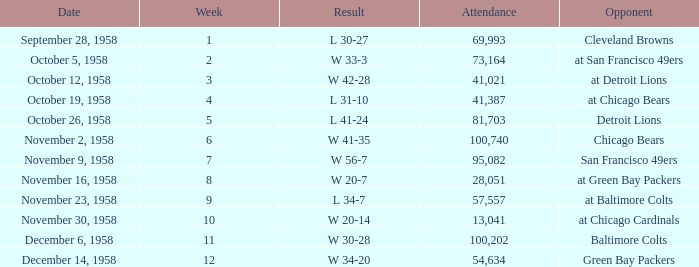What was the higest attendance on November 9, 1958? 95082.0. 